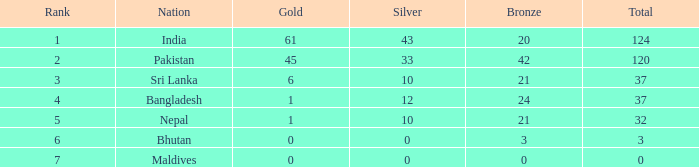Which gold has a rank less than 5, and a bronze of 20? 61.0. 